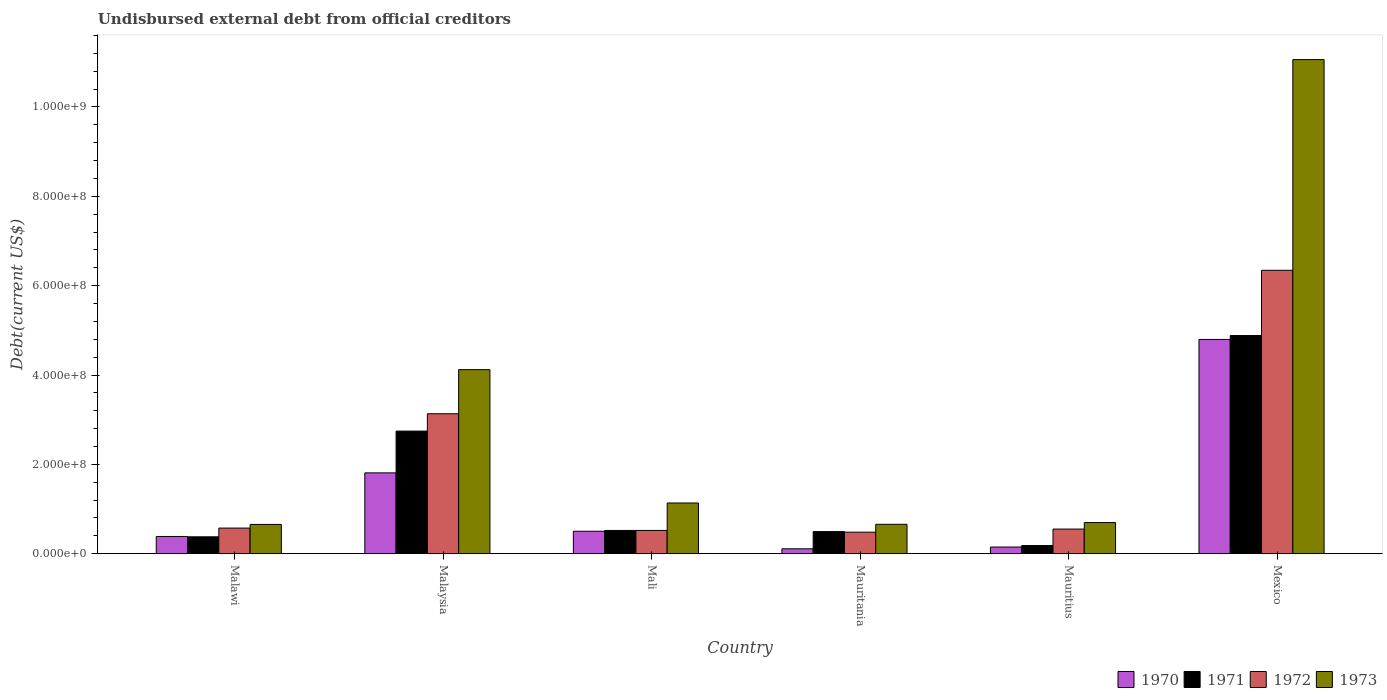How many different coloured bars are there?
Your answer should be compact. 4. How many groups of bars are there?
Ensure brevity in your answer.  6. Are the number of bars on each tick of the X-axis equal?
Provide a succinct answer. Yes. How many bars are there on the 4th tick from the left?
Offer a very short reply. 4. What is the label of the 5th group of bars from the left?
Your response must be concise. Mauritius. In how many cases, is the number of bars for a given country not equal to the number of legend labels?
Ensure brevity in your answer.  0. What is the total debt in 1971 in Mexico?
Your answer should be compact. 4.88e+08. Across all countries, what is the maximum total debt in 1972?
Keep it short and to the point. 6.34e+08. Across all countries, what is the minimum total debt in 1971?
Make the answer very short. 1.84e+07. In which country was the total debt in 1972 minimum?
Provide a short and direct response. Mauritania. What is the total total debt in 1973 in the graph?
Keep it short and to the point. 1.83e+09. What is the difference between the total debt in 1971 in Malawi and that in Mauritania?
Give a very brief answer. -1.17e+07. What is the difference between the total debt in 1972 in Malaysia and the total debt in 1973 in Mauritius?
Your answer should be very brief. 2.44e+08. What is the average total debt in 1970 per country?
Provide a short and direct response. 1.29e+08. What is the difference between the total debt of/in 1971 and total debt of/in 1970 in Mauritania?
Provide a short and direct response. 3.85e+07. What is the ratio of the total debt in 1972 in Malaysia to that in Mauritania?
Your answer should be very brief. 6.49. What is the difference between the highest and the second highest total debt in 1970?
Provide a succinct answer. 2.99e+08. What is the difference between the highest and the lowest total debt in 1973?
Your answer should be very brief. 1.04e+09. In how many countries, is the total debt in 1970 greater than the average total debt in 1970 taken over all countries?
Give a very brief answer. 2. Is the sum of the total debt in 1971 in Mali and Mauritius greater than the maximum total debt in 1970 across all countries?
Make the answer very short. No. Is it the case that in every country, the sum of the total debt in 1972 and total debt in 1971 is greater than the sum of total debt in 1970 and total debt in 1973?
Provide a succinct answer. No. What does the 4th bar from the left in Mauritania represents?
Your response must be concise. 1973. Are all the bars in the graph horizontal?
Provide a succinct answer. No. How many countries are there in the graph?
Give a very brief answer. 6. Does the graph contain grids?
Provide a succinct answer. No. Where does the legend appear in the graph?
Make the answer very short. Bottom right. How are the legend labels stacked?
Offer a terse response. Horizontal. What is the title of the graph?
Ensure brevity in your answer.  Undisbursed external debt from official creditors. What is the label or title of the Y-axis?
Give a very brief answer. Debt(current US$). What is the Debt(current US$) in 1970 in Malawi?
Provide a short and direct response. 3.87e+07. What is the Debt(current US$) of 1971 in Malawi?
Offer a terse response. 3.79e+07. What is the Debt(current US$) of 1972 in Malawi?
Your answer should be compact. 5.74e+07. What is the Debt(current US$) in 1973 in Malawi?
Keep it short and to the point. 6.56e+07. What is the Debt(current US$) in 1970 in Malaysia?
Your answer should be compact. 1.81e+08. What is the Debt(current US$) in 1971 in Malaysia?
Make the answer very short. 2.74e+08. What is the Debt(current US$) of 1972 in Malaysia?
Offer a very short reply. 3.13e+08. What is the Debt(current US$) in 1973 in Malaysia?
Give a very brief answer. 4.12e+08. What is the Debt(current US$) of 1970 in Mali?
Your answer should be very brief. 5.04e+07. What is the Debt(current US$) of 1971 in Mali?
Ensure brevity in your answer.  5.21e+07. What is the Debt(current US$) in 1972 in Mali?
Your answer should be very brief. 5.22e+07. What is the Debt(current US$) of 1973 in Mali?
Give a very brief answer. 1.14e+08. What is the Debt(current US$) of 1970 in Mauritania?
Ensure brevity in your answer.  1.10e+07. What is the Debt(current US$) in 1971 in Mauritania?
Make the answer very short. 4.96e+07. What is the Debt(current US$) in 1972 in Mauritania?
Your answer should be compact. 4.83e+07. What is the Debt(current US$) in 1973 in Mauritania?
Your response must be concise. 6.59e+07. What is the Debt(current US$) in 1970 in Mauritius?
Ensure brevity in your answer.  1.50e+07. What is the Debt(current US$) in 1971 in Mauritius?
Your answer should be very brief. 1.84e+07. What is the Debt(current US$) of 1972 in Mauritius?
Your answer should be very brief. 5.52e+07. What is the Debt(current US$) in 1973 in Mauritius?
Offer a very short reply. 6.98e+07. What is the Debt(current US$) in 1970 in Mexico?
Give a very brief answer. 4.80e+08. What is the Debt(current US$) of 1971 in Mexico?
Offer a very short reply. 4.88e+08. What is the Debt(current US$) in 1972 in Mexico?
Offer a very short reply. 6.34e+08. What is the Debt(current US$) in 1973 in Mexico?
Ensure brevity in your answer.  1.11e+09. Across all countries, what is the maximum Debt(current US$) of 1970?
Your answer should be very brief. 4.80e+08. Across all countries, what is the maximum Debt(current US$) of 1971?
Your answer should be very brief. 4.88e+08. Across all countries, what is the maximum Debt(current US$) of 1972?
Your response must be concise. 6.34e+08. Across all countries, what is the maximum Debt(current US$) in 1973?
Provide a short and direct response. 1.11e+09. Across all countries, what is the minimum Debt(current US$) in 1970?
Your response must be concise. 1.10e+07. Across all countries, what is the minimum Debt(current US$) in 1971?
Your answer should be compact. 1.84e+07. Across all countries, what is the minimum Debt(current US$) in 1972?
Make the answer very short. 4.83e+07. Across all countries, what is the minimum Debt(current US$) of 1973?
Keep it short and to the point. 6.56e+07. What is the total Debt(current US$) of 1970 in the graph?
Your answer should be very brief. 7.76e+08. What is the total Debt(current US$) of 1971 in the graph?
Provide a succinct answer. 9.21e+08. What is the total Debt(current US$) in 1972 in the graph?
Offer a very short reply. 1.16e+09. What is the total Debt(current US$) of 1973 in the graph?
Your answer should be very brief. 1.83e+09. What is the difference between the Debt(current US$) in 1970 in Malawi and that in Malaysia?
Offer a very short reply. -1.42e+08. What is the difference between the Debt(current US$) of 1971 in Malawi and that in Malaysia?
Offer a terse response. -2.37e+08. What is the difference between the Debt(current US$) in 1972 in Malawi and that in Malaysia?
Your answer should be very brief. -2.56e+08. What is the difference between the Debt(current US$) in 1973 in Malawi and that in Malaysia?
Your answer should be compact. -3.46e+08. What is the difference between the Debt(current US$) in 1970 in Malawi and that in Mali?
Your answer should be compact. -1.17e+07. What is the difference between the Debt(current US$) of 1971 in Malawi and that in Mali?
Provide a succinct answer. -1.42e+07. What is the difference between the Debt(current US$) of 1972 in Malawi and that in Mali?
Make the answer very short. 5.24e+06. What is the difference between the Debt(current US$) in 1973 in Malawi and that in Mali?
Provide a short and direct response. -4.80e+07. What is the difference between the Debt(current US$) of 1970 in Malawi and that in Mauritania?
Ensure brevity in your answer.  2.76e+07. What is the difference between the Debt(current US$) in 1971 in Malawi and that in Mauritania?
Provide a succinct answer. -1.17e+07. What is the difference between the Debt(current US$) in 1972 in Malawi and that in Mauritania?
Your answer should be compact. 9.13e+06. What is the difference between the Debt(current US$) of 1973 in Malawi and that in Mauritania?
Ensure brevity in your answer.  -3.01e+05. What is the difference between the Debt(current US$) in 1970 in Malawi and that in Mauritius?
Ensure brevity in your answer.  2.36e+07. What is the difference between the Debt(current US$) of 1971 in Malawi and that in Mauritius?
Ensure brevity in your answer.  1.95e+07. What is the difference between the Debt(current US$) in 1972 in Malawi and that in Mauritius?
Your response must be concise. 2.22e+06. What is the difference between the Debt(current US$) in 1973 in Malawi and that in Mauritius?
Give a very brief answer. -4.20e+06. What is the difference between the Debt(current US$) of 1970 in Malawi and that in Mexico?
Ensure brevity in your answer.  -4.41e+08. What is the difference between the Debt(current US$) in 1971 in Malawi and that in Mexico?
Keep it short and to the point. -4.50e+08. What is the difference between the Debt(current US$) of 1972 in Malawi and that in Mexico?
Offer a very short reply. -5.77e+08. What is the difference between the Debt(current US$) in 1973 in Malawi and that in Mexico?
Give a very brief answer. -1.04e+09. What is the difference between the Debt(current US$) of 1970 in Malaysia and that in Mali?
Make the answer very short. 1.31e+08. What is the difference between the Debt(current US$) in 1971 in Malaysia and that in Mali?
Provide a succinct answer. 2.22e+08. What is the difference between the Debt(current US$) of 1972 in Malaysia and that in Mali?
Your answer should be compact. 2.61e+08. What is the difference between the Debt(current US$) of 1973 in Malaysia and that in Mali?
Provide a succinct answer. 2.98e+08. What is the difference between the Debt(current US$) in 1970 in Malaysia and that in Mauritania?
Your response must be concise. 1.70e+08. What is the difference between the Debt(current US$) of 1971 in Malaysia and that in Mauritania?
Provide a succinct answer. 2.25e+08. What is the difference between the Debt(current US$) of 1972 in Malaysia and that in Mauritania?
Your response must be concise. 2.65e+08. What is the difference between the Debt(current US$) of 1973 in Malaysia and that in Mauritania?
Offer a very short reply. 3.46e+08. What is the difference between the Debt(current US$) in 1970 in Malaysia and that in Mauritius?
Provide a succinct answer. 1.66e+08. What is the difference between the Debt(current US$) of 1971 in Malaysia and that in Mauritius?
Provide a short and direct response. 2.56e+08. What is the difference between the Debt(current US$) in 1972 in Malaysia and that in Mauritius?
Your answer should be compact. 2.58e+08. What is the difference between the Debt(current US$) in 1973 in Malaysia and that in Mauritius?
Your answer should be very brief. 3.42e+08. What is the difference between the Debt(current US$) in 1970 in Malaysia and that in Mexico?
Keep it short and to the point. -2.99e+08. What is the difference between the Debt(current US$) of 1971 in Malaysia and that in Mexico?
Give a very brief answer. -2.14e+08. What is the difference between the Debt(current US$) of 1972 in Malaysia and that in Mexico?
Provide a short and direct response. -3.21e+08. What is the difference between the Debt(current US$) in 1973 in Malaysia and that in Mexico?
Provide a succinct answer. -6.94e+08. What is the difference between the Debt(current US$) of 1970 in Mali and that in Mauritania?
Give a very brief answer. 3.93e+07. What is the difference between the Debt(current US$) in 1971 in Mali and that in Mauritania?
Give a very brief answer. 2.51e+06. What is the difference between the Debt(current US$) in 1972 in Mali and that in Mauritania?
Provide a succinct answer. 3.90e+06. What is the difference between the Debt(current US$) of 1973 in Mali and that in Mauritania?
Provide a short and direct response. 4.77e+07. What is the difference between the Debt(current US$) of 1970 in Mali and that in Mauritius?
Your response must be concise. 3.53e+07. What is the difference between the Debt(current US$) of 1971 in Mali and that in Mauritius?
Give a very brief answer. 3.37e+07. What is the difference between the Debt(current US$) of 1972 in Mali and that in Mauritius?
Ensure brevity in your answer.  -3.02e+06. What is the difference between the Debt(current US$) in 1973 in Mali and that in Mauritius?
Offer a terse response. 4.38e+07. What is the difference between the Debt(current US$) of 1970 in Mali and that in Mexico?
Keep it short and to the point. -4.29e+08. What is the difference between the Debt(current US$) of 1971 in Mali and that in Mexico?
Provide a succinct answer. -4.36e+08. What is the difference between the Debt(current US$) of 1972 in Mali and that in Mexico?
Provide a short and direct response. -5.82e+08. What is the difference between the Debt(current US$) in 1973 in Mali and that in Mexico?
Your answer should be compact. -9.92e+08. What is the difference between the Debt(current US$) of 1970 in Mauritania and that in Mauritius?
Provide a succinct answer. -4.00e+06. What is the difference between the Debt(current US$) of 1971 in Mauritania and that in Mauritius?
Give a very brief answer. 3.12e+07. What is the difference between the Debt(current US$) in 1972 in Mauritania and that in Mauritius?
Keep it short and to the point. -6.91e+06. What is the difference between the Debt(current US$) in 1973 in Mauritania and that in Mauritius?
Offer a terse response. -3.90e+06. What is the difference between the Debt(current US$) of 1970 in Mauritania and that in Mexico?
Your answer should be compact. -4.69e+08. What is the difference between the Debt(current US$) of 1971 in Mauritania and that in Mexico?
Offer a very short reply. -4.39e+08. What is the difference between the Debt(current US$) of 1972 in Mauritania and that in Mexico?
Keep it short and to the point. -5.86e+08. What is the difference between the Debt(current US$) in 1973 in Mauritania and that in Mexico?
Give a very brief answer. -1.04e+09. What is the difference between the Debt(current US$) of 1970 in Mauritius and that in Mexico?
Your response must be concise. -4.65e+08. What is the difference between the Debt(current US$) of 1971 in Mauritius and that in Mexico?
Provide a succinct answer. -4.70e+08. What is the difference between the Debt(current US$) in 1972 in Mauritius and that in Mexico?
Provide a short and direct response. -5.79e+08. What is the difference between the Debt(current US$) in 1973 in Mauritius and that in Mexico?
Offer a very short reply. -1.04e+09. What is the difference between the Debt(current US$) of 1970 in Malawi and the Debt(current US$) of 1971 in Malaysia?
Your answer should be very brief. -2.36e+08. What is the difference between the Debt(current US$) of 1970 in Malawi and the Debt(current US$) of 1972 in Malaysia?
Keep it short and to the point. -2.75e+08. What is the difference between the Debt(current US$) of 1970 in Malawi and the Debt(current US$) of 1973 in Malaysia?
Provide a succinct answer. -3.73e+08. What is the difference between the Debt(current US$) of 1971 in Malawi and the Debt(current US$) of 1972 in Malaysia?
Give a very brief answer. -2.75e+08. What is the difference between the Debt(current US$) of 1971 in Malawi and the Debt(current US$) of 1973 in Malaysia?
Your answer should be very brief. -3.74e+08. What is the difference between the Debt(current US$) of 1972 in Malawi and the Debt(current US$) of 1973 in Malaysia?
Ensure brevity in your answer.  -3.55e+08. What is the difference between the Debt(current US$) in 1970 in Malawi and the Debt(current US$) in 1971 in Mali?
Keep it short and to the point. -1.34e+07. What is the difference between the Debt(current US$) in 1970 in Malawi and the Debt(current US$) in 1972 in Mali?
Make the answer very short. -1.35e+07. What is the difference between the Debt(current US$) of 1970 in Malawi and the Debt(current US$) of 1973 in Mali?
Your response must be concise. -7.49e+07. What is the difference between the Debt(current US$) in 1971 in Malawi and the Debt(current US$) in 1972 in Mali?
Your response must be concise. -1.43e+07. What is the difference between the Debt(current US$) of 1971 in Malawi and the Debt(current US$) of 1973 in Mali?
Provide a succinct answer. -7.57e+07. What is the difference between the Debt(current US$) in 1972 in Malawi and the Debt(current US$) in 1973 in Mali?
Offer a very short reply. -5.61e+07. What is the difference between the Debt(current US$) in 1970 in Malawi and the Debt(current US$) in 1971 in Mauritania?
Offer a very short reply. -1.09e+07. What is the difference between the Debt(current US$) of 1970 in Malawi and the Debt(current US$) of 1972 in Mauritania?
Ensure brevity in your answer.  -9.63e+06. What is the difference between the Debt(current US$) of 1970 in Malawi and the Debt(current US$) of 1973 in Mauritania?
Make the answer very short. -2.72e+07. What is the difference between the Debt(current US$) in 1971 in Malawi and the Debt(current US$) in 1972 in Mauritania?
Your answer should be very brief. -1.04e+07. What is the difference between the Debt(current US$) in 1971 in Malawi and the Debt(current US$) in 1973 in Mauritania?
Make the answer very short. -2.80e+07. What is the difference between the Debt(current US$) in 1972 in Malawi and the Debt(current US$) in 1973 in Mauritania?
Offer a terse response. -8.47e+06. What is the difference between the Debt(current US$) in 1970 in Malawi and the Debt(current US$) in 1971 in Mauritius?
Your answer should be very brief. 2.03e+07. What is the difference between the Debt(current US$) of 1970 in Malawi and the Debt(current US$) of 1972 in Mauritius?
Provide a succinct answer. -1.65e+07. What is the difference between the Debt(current US$) in 1970 in Malawi and the Debt(current US$) in 1973 in Mauritius?
Make the answer very short. -3.11e+07. What is the difference between the Debt(current US$) of 1971 in Malawi and the Debt(current US$) of 1972 in Mauritius?
Offer a very short reply. -1.73e+07. What is the difference between the Debt(current US$) of 1971 in Malawi and the Debt(current US$) of 1973 in Mauritius?
Give a very brief answer. -3.19e+07. What is the difference between the Debt(current US$) in 1972 in Malawi and the Debt(current US$) in 1973 in Mauritius?
Provide a short and direct response. -1.24e+07. What is the difference between the Debt(current US$) in 1970 in Malawi and the Debt(current US$) in 1971 in Mexico?
Make the answer very short. -4.50e+08. What is the difference between the Debt(current US$) of 1970 in Malawi and the Debt(current US$) of 1972 in Mexico?
Keep it short and to the point. -5.96e+08. What is the difference between the Debt(current US$) of 1970 in Malawi and the Debt(current US$) of 1973 in Mexico?
Your answer should be very brief. -1.07e+09. What is the difference between the Debt(current US$) of 1971 in Malawi and the Debt(current US$) of 1972 in Mexico?
Offer a very short reply. -5.96e+08. What is the difference between the Debt(current US$) in 1971 in Malawi and the Debt(current US$) in 1973 in Mexico?
Provide a short and direct response. -1.07e+09. What is the difference between the Debt(current US$) in 1972 in Malawi and the Debt(current US$) in 1973 in Mexico?
Offer a terse response. -1.05e+09. What is the difference between the Debt(current US$) in 1970 in Malaysia and the Debt(current US$) in 1971 in Mali?
Provide a short and direct response. 1.29e+08. What is the difference between the Debt(current US$) in 1970 in Malaysia and the Debt(current US$) in 1972 in Mali?
Provide a short and direct response. 1.29e+08. What is the difference between the Debt(current US$) of 1970 in Malaysia and the Debt(current US$) of 1973 in Mali?
Offer a very short reply. 6.74e+07. What is the difference between the Debt(current US$) in 1971 in Malaysia and the Debt(current US$) in 1972 in Mali?
Offer a very short reply. 2.22e+08. What is the difference between the Debt(current US$) in 1971 in Malaysia and the Debt(current US$) in 1973 in Mali?
Give a very brief answer. 1.61e+08. What is the difference between the Debt(current US$) in 1972 in Malaysia and the Debt(current US$) in 1973 in Mali?
Keep it short and to the point. 2.00e+08. What is the difference between the Debt(current US$) in 1970 in Malaysia and the Debt(current US$) in 1971 in Mauritania?
Offer a terse response. 1.31e+08. What is the difference between the Debt(current US$) of 1970 in Malaysia and the Debt(current US$) of 1972 in Mauritania?
Your answer should be very brief. 1.33e+08. What is the difference between the Debt(current US$) of 1970 in Malaysia and the Debt(current US$) of 1973 in Mauritania?
Offer a very short reply. 1.15e+08. What is the difference between the Debt(current US$) of 1971 in Malaysia and the Debt(current US$) of 1972 in Mauritania?
Provide a succinct answer. 2.26e+08. What is the difference between the Debt(current US$) of 1971 in Malaysia and the Debt(current US$) of 1973 in Mauritania?
Make the answer very short. 2.09e+08. What is the difference between the Debt(current US$) of 1972 in Malaysia and the Debt(current US$) of 1973 in Mauritania?
Your answer should be compact. 2.47e+08. What is the difference between the Debt(current US$) of 1970 in Malaysia and the Debt(current US$) of 1971 in Mauritius?
Keep it short and to the point. 1.63e+08. What is the difference between the Debt(current US$) in 1970 in Malaysia and the Debt(current US$) in 1972 in Mauritius?
Provide a short and direct response. 1.26e+08. What is the difference between the Debt(current US$) in 1970 in Malaysia and the Debt(current US$) in 1973 in Mauritius?
Your answer should be very brief. 1.11e+08. What is the difference between the Debt(current US$) in 1971 in Malaysia and the Debt(current US$) in 1972 in Mauritius?
Offer a very short reply. 2.19e+08. What is the difference between the Debt(current US$) in 1971 in Malaysia and the Debt(current US$) in 1973 in Mauritius?
Ensure brevity in your answer.  2.05e+08. What is the difference between the Debt(current US$) of 1972 in Malaysia and the Debt(current US$) of 1973 in Mauritius?
Offer a very short reply. 2.44e+08. What is the difference between the Debt(current US$) in 1970 in Malaysia and the Debt(current US$) in 1971 in Mexico?
Offer a very short reply. -3.07e+08. What is the difference between the Debt(current US$) of 1970 in Malaysia and the Debt(current US$) of 1972 in Mexico?
Offer a very short reply. -4.53e+08. What is the difference between the Debt(current US$) of 1970 in Malaysia and the Debt(current US$) of 1973 in Mexico?
Provide a short and direct response. -9.25e+08. What is the difference between the Debt(current US$) of 1971 in Malaysia and the Debt(current US$) of 1972 in Mexico?
Provide a short and direct response. -3.60e+08. What is the difference between the Debt(current US$) of 1971 in Malaysia and the Debt(current US$) of 1973 in Mexico?
Offer a very short reply. -8.31e+08. What is the difference between the Debt(current US$) in 1972 in Malaysia and the Debt(current US$) in 1973 in Mexico?
Your response must be concise. -7.93e+08. What is the difference between the Debt(current US$) in 1970 in Mali and the Debt(current US$) in 1971 in Mauritania?
Provide a succinct answer. 7.72e+05. What is the difference between the Debt(current US$) in 1970 in Mali and the Debt(current US$) in 1972 in Mauritania?
Provide a short and direct response. 2.07e+06. What is the difference between the Debt(current US$) of 1970 in Mali and the Debt(current US$) of 1973 in Mauritania?
Offer a terse response. -1.55e+07. What is the difference between the Debt(current US$) in 1971 in Mali and the Debt(current US$) in 1972 in Mauritania?
Your response must be concise. 3.81e+06. What is the difference between the Debt(current US$) of 1971 in Mali and the Debt(current US$) of 1973 in Mauritania?
Ensure brevity in your answer.  -1.38e+07. What is the difference between the Debt(current US$) in 1972 in Mali and the Debt(current US$) in 1973 in Mauritania?
Make the answer very short. -1.37e+07. What is the difference between the Debt(current US$) of 1970 in Mali and the Debt(current US$) of 1971 in Mauritius?
Keep it short and to the point. 3.20e+07. What is the difference between the Debt(current US$) of 1970 in Mali and the Debt(current US$) of 1972 in Mauritius?
Keep it short and to the point. -4.84e+06. What is the difference between the Debt(current US$) in 1970 in Mali and the Debt(current US$) in 1973 in Mauritius?
Offer a terse response. -1.94e+07. What is the difference between the Debt(current US$) in 1971 in Mali and the Debt(current US$) in 1972 in Mauritius?
Make the answer very short. -3.10e+06. What is the difference between the Debt(current US$) in 1971 in Mali and the Debt(current US$) in 1973 in Mauritius?
Give a very brief answer. -1.77e+07. What is the difference between the Debt(current US$) in 1972 in Mali and the Debt(current US$) in 1973 in Mauritius?
Give a very brief answer. -1.76e+07. What is the difference between the Debt(current US$) of 1970 in Mali and the Debt(current US$) of 1971 in Mexico?
Ensure brevity in your answer.  -4.38e+08. What is the difference between the Debt(current US$) in 1970 in Mali and the Debt(current US$) in 1972 in Mexico?
Give a very brief answer. -5.84e+08. What is the difference between the Debt(current US$) in 1970 in Mali and the Debt(current US$) in 1973 in Mexico?
Offer a very short reply. -1.06e+09. What is the difference between the Debt(current US$) of 1971 in Mali and the Debt(current US$) of 1972 in Mexico?
Your answer should be very brief. -5.82e+08. What is the difference between the Debt(current US$) in 1971 in Mali and the Debt(current US$) in 1973 in Mexico?
Provide a short and direct response. -1.05e+09. What is the difference between the Debt(current US$) in 1972 in Mali and the Debt(current US$) in 1973 in Mexico?
Give a very brief answer. -1.05e+09. What is the difference between the Debt(current US$) of 1970 in Mauritania and the Debt(current US$) of 1971 in Mauritius?
Your response must be concise. -7.33e+06. What is the difference between the Debt(current US$) of 1970 in Mauritania and the Debt(current US$) of 1972 in Mauritius?
Provide a succinct answer. -4.42e+07. What is the difference between the Debt(current US$) in 1970 in Mauritania and the Debt(current US$) in 1973 in Mauritius?
Offer a terse response. -5.88e+07. What is the difference between the Debt(current US$) in 1971 in Mauritania and the Debt(current US$) in 1972 in Mauritius?
Your answer should be compact. -5.62e+06. What is the difference between the Debt(current US$) of 1971 in Mauritania and the Debt(current US$) of 1973 in Mauritius?
Your answer should be compact. -2.02e+07. What is the difference between the Debt(current US$) of 1972 in Mauritania and the Debt(current US$) of 1973 in Mauritius?
Ensure brevity in your answer.  -2.15e+07. What is the difference between the Debt(current US$) in 1970 in Mauritania and the Debt(current US$) in 1971 in Mexico?
Offer a terse response. -4.77e+08. What is the difference between the Debt(current US$) in 1970 in Mauritania and the Debt(current US$) in 1972 in Mexico?
Offer a terse response. -6.23e+08. What is the difference between the Debt(current US$) of 1970 in Mauritania and the Debt(current US$) of 1973 in Mexico?
Provide a succinct answer. -1.09e+09. What is the difference between the Debt(current US$) of 1971 in Mauritania and the Debt(current US$) of 1972 in Mexico?
Your answer should be very brief. -5.85e+08. What is the difference between the Debt(current US$) of 1971 in Mauritania and the Debt(current US$) of 1973 in Mexico?
Give a very brief answer. -1.06e+09. What is the difference between the Debt(current US$) of 1972 in Mauritania and the Debt(current US$) of 1973 in Mexico?
Offer a very short reply. -1.06e+09. What is the difference between the Debt(current US$) of 1970 in Mauritius and the Debt(current US$) of 1971 in Mexico?
Your response must be concise. -4.73e+08. What is the difference between the Debt(current US$) of 1970 in Mauritius and the Debt(current US$) of 1972 in Mexico?
Ensure brevity in your answer.  -6.19e+08. What is the difference between the Debt(current US$) of 1970 in Mauritius and the Debt(current US$) of 1973 in Mexico?
Offer a terse response. -1.09e+09. What is the difference between the Debt(current US$) in 1971 in Mauritius and the Debt(current US$) in 1972 in Mexico?
Your response must be concise. -6.16e+08. What is the difference between the Debt(current US$) in 1971 in Mauritius and the Debt(current US$) in 1973 in Mexico?
Give a very brief answer. -1.09e+09. What is the difference between the Debt(current US$) of 1972 in Mauritius and the Debt(current US$) of 1973 in Mexico?
Your response must be concise. -1.05e+09. What is the average Debt(current US$) of 1970 per country?
Provide a succinct answer. 1.29e+08. What is the average Debt(current US$) in 1971 per country?
Your response must be concise. 1.53e+08. What is the average Debt(current US$) of 1972 per country?
Provide a succinct answer. 1.93e+08. What is the average Debt(current US$) of 1973 per country?
Ensure brevity in your answer.  3.05e+08. What is the difference between the Debt(current US$) of 1970 and Debt(current US$) of 1971 in Malawi?
Your response must be concise. 7.85e+05. What is the difference between the Debt(current US$) of 1970 and Debt(current US$) of 1972 in Malawi?
Provide a succinct answer. -1.88e+07. What is the difference between the Debt(current US$) of 1970 and Debt(current US$) of 1973 in Malawi?
Your answer should be compact. -2.69e+07. What is the difference between the Debt(current US$) of 1971 and Debt(current US$) of 1972 in Malawi?
Your answer should be very brief. -1.95e+07. What is the difference between the Debt(current US$) of 1971 and Debt(current US$) of 1973 in Malawi?
Your answer should be compact. -2.77e+07. What is the difference between the Debt(current US$) in 1972 and Debt(current US$) in 1973 in Malawi?
Provide a short and direct response. -8.17e+06. What is the difference between the Debt(current US$) of 1970 and Debt(current US$) of 1971 in Malaysia?
Your answer should be compact. -9.35e+07. What is the difference between the Debt(current US$) of 1970 and Debt(current US$) of 1972 in Malaysia?
Keep it short and to the point. -1.32e+08. What is the difference between the Debt(current US$) in 1970 and Debt(current US$) in 1973 in Malaysia?
Give a very brief answer. -2.31e+08. What is the difference between the Debt(current US$) in 1971 and Debt(current US$) in 1972 in Malaysia?
Your response must be concise. -3.88e+07. What is the difference between the Debt(current US$) of 1971 and Debt(current US$) of 1973 in Malaysia?
Ensure brevity in your answer.  -1.38e+08. What is the difference between the Debt(current US$) of 1972 and Debt(current US$) of 1973 in Malaysia?
Your response must be concise. -9.87e+07. What is the difference between the Debt(current US$) of 1970 and Debt(current US$) of 1971 in Mali?
Give a very brief answer. -1.74e+06. What is the difference between the Debt(current US$) of 1970 and Debt(current US$) of 1972 in Mali?
Your response must be concise. -1.82e+06. What is the difference between the Debt(current US$) in 1970 and Debt(current US$) in 1973 in Mali?
Ensure brevity in your answer.  -6.32e+07. What is the difference between the Debt(current US$) in 1971 and Debt(current US$) in 1972 in Mali?
Ensure brevity in your answer.  -8.30e+04. What is the difference between the Debt(current US$) of 1971 and Debt(current US$) of 1973 in Mali?
Offer a terse response. -6.15e+07. What is the difference between the Debt(current US$) of 1972 and Debt(current US$) of 1973 in Mali?
Provide a short and direct response. -6.14e+07. What is the difference between the Debt(current US$) in 1970 and Debt(current US$) in 1971 in Mauritania?
Provide a short and direct response. -3.85e+07. What is the difference between the Debt(current US$) in 1970 and Debt(current US$) in 1972 in Mauritania?
Provide a short and direct response. -3.72e+07. What is the difference between the Debt(current US$) of 1970 and Debt(current US$) of 1973 in Mauritania?
Your answer should be very brief. -5.49e+07. What is the difference between the Debt(current US$) of 1971 and Debt(current US$) of 1972 in Mauritania?
Provide a succinct answer. 1.30e+06. What is the difference between the Debt(current US$) in 1971 and Debt(current US$) in 1973 in Mauritania?
Make the answer very short. -1.63e+07. What is the difference between the Debt(current US$) in 1972 and Debt(current US$) in 1973 in Mauritania?
Provide a short and direct response. -1.76e+07. What is the difference between the Debt(current US$) in 1970 and Debt(current US$) in 1971 in Mauritius?
Your answer should be compact. -3.32e+06. What is the difference between the Debt(current US$) of 1970 and Debt(current US$) of 1972 in Mauritius?
Make the answer very short. -4.02e+07. What is the difference between the Debt(current US$) in 1970 and Debt(current US$) in 1973 in Mauritius?
Provide a short and direct response. -5.47e+07. What is the difference between the Debt(current US$) in 1971 and Debt(current US$) in 1972 in Mauritius?
Your answer should be very brief. -3.68e+07. What is the difference between the Debt(current US$) in 1971 and Debt(current US$) in 1973 in Mauritius?
Ensure brevity in your answer.  -5.14e+07. What is the difference between the Debt(current US$) of 1972 and Debt(current US$) of 1973 in Mauritius?
Your answer should be compact. -1.46e+07. What is the difference between the Debt(current US$) in 1970 and Debt(current US$) in 1971 in Mexico?
Make the answer very short. -8.70e+06. What is the difference between the Debt(current US$) in 1970 and Debt(current US$) in 1972 in Mexico?
Keep it short and to the point. -1.55e+08. What is the difference between the Debt(current US$) of 1970 and Debt(current US$) of 1973 in Mexico?
Ensure brevity in your answer.  -6.26e+08. What is the difference between the Debt(current US$) of 1971 and Debt(current US$) of 1972 in Mexico?
Ensure brevity in your answer.  -1.46e+08. What is the difference between the Debt(current US$) of 1971 and Debt(current US$) of 1973 in Mexico?
Make the answer very short. -6.18e+08. What is the difference between the Debt(current US$) of 1972 and Debt(current US$) of 1973 in Mexico?
Give a very brief answer. -4.72e+08. What is the ratio of the Debt(current US$) of 1970 in Malawi to that in Malaysia?
Provide a succinct answer. 0.21. What is the ratio of the Debt(current US$) in 1971 in Malawi to that in Malaysia?
Your answer should be very brief. 0.14. What is the ratio of the Debt(current US$) of 1972 in Malawi to that in Malaysia?
Offer a terse response. 0.18. What is the ratio of the Debt(current US$) in 1973 in Malawi to that in Malaysia?
Make the answer very short. 0.16. What is the ratio of the Debt(current US$) in 1970 in Malawi to that in Mali?
Make the answer very short. 0.77. What is the ratio of the Debt(current US$) of 1971 in Malawi to that in Mali?
Your response must be concise. 0.73. What is the ratio of the Debt(current US$) in 1972 in Malawi to that in Mali?
Offer a very short reply. 1.1. What is the ratio of the Debt(current US$) in 1973 in Malawi to that in Mali?
Offer a terse response. 0.58. What is the ratio of the Debt(current US$) in 1970 in Malawi to that in Mauritania?
Your response must be concise. 3.5. What is the ratio of the Debt(current US$) of 1971 in Malawi to that in Mauritania?
Provide a short and direct response. 0.76. What is the ratio of the Debt(current US$) of 1972 in Malawi to that in Mauritania?
Offer a terse response. 1.19. What is the ratio of the Debt(current US$) of 1973 in Malawi to that in Mauritania?
Give a very brief answer. 1. What is the ratio of the Debt(current US$) in 1970 in Malawi to that in Mauritius?
Offer a terse response. 2.57. What is the ratio of the Debt(current US$) of 1971 in Malawi to that in Mauritius?
Your answer should be compact. 2.06. What is the ratio of the Debt(current US$) in 1972 in Malawi to that in Mauritius?
Offer a very short reply. 1.04. What is the ratio of the Debt(current US$) of 1973 in Malawi to that in Mauritius?
Give a very brief answer. 0.94. What is the ratio of the Debt(current US$) in 1970 in Malawi to that in Mexico?
Provide a succinct answer. 0.08. What is the ratio of the Debt(current US$) of 1971 in Malawi to that in Mexico?
Offer a terse response. 0.08. What is the ratio of the Debt(current US$) in 1972 in Malawi to that in Mexico?
Provide a short and direct response. 0.09. What is the ratio of the Debt(current US$) of 1973 in Malawi to that in Mexico?
Your response must be concise. 0.06. What is the ratio of the Debt(current US$) in 1970 in Malaysia to that in Mali?
Your response must be concise. 3.59. What is the ratio of the Debt(current US$) in 1971 in Malaysia to that in Mali?
Your answer should be very brief. 5.27. What is the ratio of the Debt(current US$) in 1972 in Malaysia to that in Mali?
Your answer should be compact. 6. What is the ratio of the Debt(current US$) of 1973 in Malaysia to that in Mali?
Give a very brief answer. 3.63. What is the ratio of the Debt(current US$) of 1970 in Malaysia to that in Mauritania?
Offer a very short reply. 16.39. What is the ratio of the Debt(current US$) of 1971 in Malaysia to that in Mauritania?
Your answer should be very brief. 5.54. What is the ratio of the Debt(current US$) of 1972 in Malaysia to that in Mauritania?
Provide a short and direct response. 6.49. What is the ratio of the Debt(current US$) in 1973 in Malaysia to that in Mauritania?
Your response must be concise. 6.25. What is the ratio of the Debt(current US$) of 1970 in Malaysia to that in Mauritius?
Your answer should be very brief. 12.03. What is the ratio of the Debt(current US$) in 1971 in Malaysia to that in Mauritius?
Make the answer very short. 14.94. What is the ratio of the Debt(current US$) of 1972 in Malaysia to that in Mauritius?
Keep it short and to the point. 5.68. What is the ratio of the Debt(current US$) of 1973 in Malaysia to that in Mauritius?
Your answer should be very brief. 5.9. What is the ratio of the Debt(current US$) in 1970 in Malaysia to that in Mexico?
Provide a succinct answer. 0.38. What is the ratio of the Debt(current US$) in 1971 in Malaysia to that in Mexico?
Ensure brevity in your answer.  0.56. What is the ratio of the Debt(current US$) in 1972 in Malaysia to that in Mexico?
Provide a short and direct response. 0.49. What is the ratio of the Debt(current US$) of 1973 in Malaysia to that in Mexico?
Keep it short and to the point. 0.37. What is the ratio of the Debt(current US$) of 1970 in Mali to that in Mauritania?
Ensure brevity in your answer.  4.56. What is the ratio of the Debt(current US$) in 1971 in Mali to that in Mauritania?
Offer a terse response. 1.05. What is the ratio of the Debt(current US$) of 1972 in Mali to that in Mauritania?
Give a very brief answer. 1.08. What is the ratio of the Debt(current US$) of 1973 in Mali to that in Mauritania?
Provide a short and direct response. 1.72. What is the ratio of the Debt(current US$) of 1970 in Mali to that in Mauritius?
Make the answer very short. 3.35. What is the ratio of the Debt(current US$) in 1971 in Mali to that in Mauritius?
Keep it short and to the point. 2.84. What is the ratio of the Debt(current US$) in 1972 in Mali to that in Mauritius?
Make the answer very short. 0.95. What is the ratio of the Debt(current US$) in 1973 in Mali to that in Mauritius?
Your answer should be compact. 1.63. What is the ratio of the Debt(current US$) of 1970 in Mali to that in Mexico?
Provide a short and direct response. 0.1. What is the ratio of the Debt(current US$) of 1971 in Mali to that in Mexico?
Offer a terse response. 0.11. What is the ratio of the Debt(current US$) in 1972 in Mali to that in Mexico?
Keep it short and to the point. 0.08. What is the ratio of the Debt(current US$) of 1973 in Mali to that in Mexico?
Offer a terse response. 0.1. What is the ratio of the Debt(current US$) in 1970 in Mauritania to that in Mauritius?
Keep it short and to the point. 0.73. What is the ratio of the Debt(current US$) in 1971 in Mauritania to that in Mauritius?
Provide a short and direct response. 2.7. What is the ratio of the Debt(current US$) in 1972 in Mauritania to that in Mauritius?
Offer a very short reply. 0.87. What is the ratio of the Debt(current US$) of 1973 in Mauritania to that in Mauritius?
Provide a short and direct response. 0.94. What is the ratio of the Debt(current US$) of 1970 in Mauritania to that in Mexico?
Give a very brief answer. 0.02. What is the ratio of the Debt(current US$) in 1971 in Mauritania to that in Mexico?
Your answer should be compact. 0.1. What is the ratio of the Debt(current US$) of 1972 in Mauritania to that in Mexico?
Keep it short and to the point. 0.08. What is the ratio of the Debt(current US$) in 1973 in Mauritania to that in Mexico?
Provide a succinct answer. 0.06. What is the ratio of the Debt(current US$) of 1970 in Mauritius to that in Mexico?
Ensure brevity in your answer.  0.03. What is the ratio of the Debt(current US$) in 1971 in Mauritius to that in Mexico?
Keep it short and to the point. 0.04. What is the ratio of the Debt(current US$) in 1972 in Mauritius to that in Mexico?
Your response must be concise. 0.09. What is the ratio of the Debt(current US$) in 1973 in Mauritius to that in Mexico?
Offer a very short reply. 0.06. What is the difference between the highest and the second highest Debt(current US$) of 1970?
Make the answer very short. 2.99e+08. What is the difference between the highest and the second highest Debt(current US$) in 1971?
Ensure brevity in your answer.  2.14e+08. What is the difference between the highest and the second highest Debt(current US$) of 1972?
Your answer should be very brief. 3.21e+08. What is the difference between the highest and the second highest Debt(current US$) in 1973?
Your response must be concise. 6.94e+08. What is the difference between the highest and the lowest Debt(current US$) of 1970?
Offer a very short reply. 4.69e+08. What is the difference between the highest and the lowest Debt(current US$) of 1971?
Offer a very short reply. 4.70e+08. What is the difference between the highest and the lowest Debt(current US$) of 1972?
Give a very brief answer. 5.86e+08. What is the difference between the highest and the lowest Debt(current US$) in 1973?
Provide a succinct answer. 1.04e+09. 